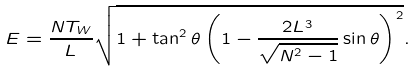Convert formula to latex. <formula><loc_0><loc_0><loc_500><loc_500>E = \frac { N T _ { W } } { L } \sqrt { 1 + \tan ^ { 2 } \theta \left ( 1 - { \frac { 2 L ^ { 3 } } { \sqrt { N ^ { 2 } - 1 } } } \sin \theta \right ) ^ { 2 } } .</formula> 